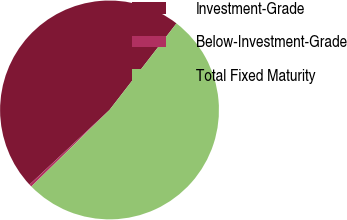<chart> <loc_0><loc_0><loc_500><loc_500><pie_chart><fcel>Investment-Grade<fcel>Below-Investment-Grade<fcel>Total Fixed Maturity<nl><fcel>47.43%<fcel>0.39%<fcel>52.18%<nl></chart> 